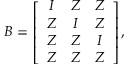<formula> <loc_0><loc_0><loc_500><loc_500>B = \left [ \begin{array} { c c c } { I } & { Z } & { Z } \\ { Z } & { I } & { Z } \\ { Z } & { Z } & { I } \\ { Z } & { Z } & { Z } \end{array} \right ] ,</formula> 